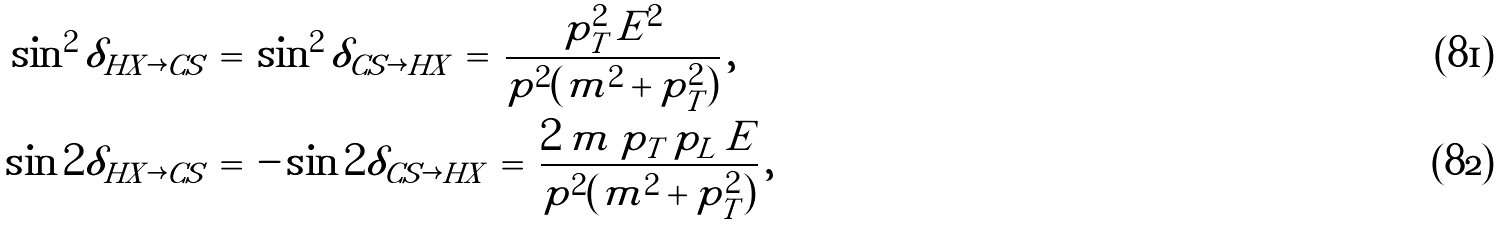Convert formula to latex. <formula><loc_0><loc_0><loc_500><loc_500>\sin ^ { 2 } \delta _ { H X \rightarrow C S } \, & = \, \sin ^ { 2 } \delta _ { C S \rightarrow H X } \, = \, \frac { p _ { T } ^ { 2 } \, E ^ { 2 } } { p ^ { 2 } ( m ^ { 2 } + p _ { T } ^ { 2 } ) } \, , \\ \sin 2 \delta _ { H X \rightarrow C S } \, & = \, - \sin 2 \delta _ { C S \rightarrow H X } \, = \, \frac { 2 \, m \, p _ { T } \, p _ { L } \, E } { p ^ { 2 } ( m ^ { 2 } + p _ { T } ^ { 2 } ) } \, ,</formula> 